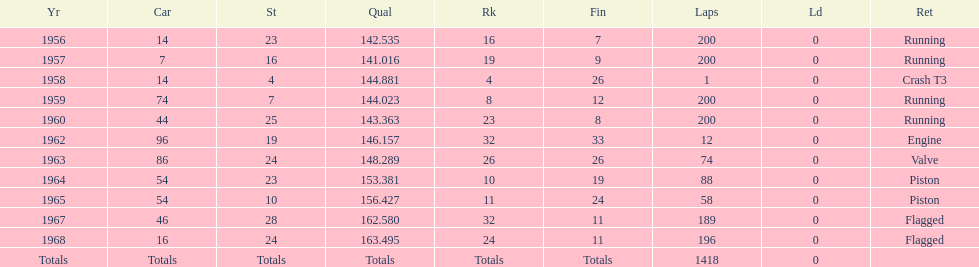How many times was bob veith ranked higher than 10 at an indy 500? 2. 